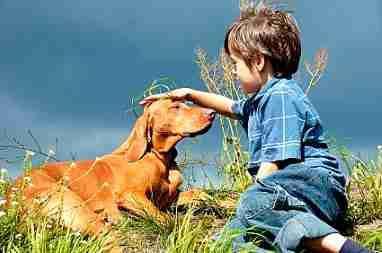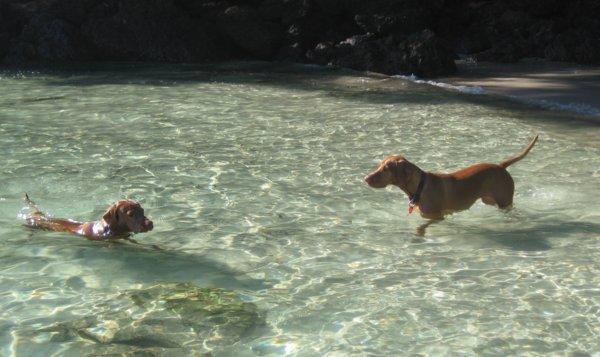The first image is the image on the left, the second image is the image on the right. Given the left and right images, does the statement "A boy and a dog face toward each other in one image, and two dogs are in a natural body of water in the other image." hold true? Answer yes or no. Yes. The first image is the image on the left, the second image is the image on the right. Analyze the images presented: Is the assertion "The left image contains exactly two dogs." valid? Answer yes or no. No. 